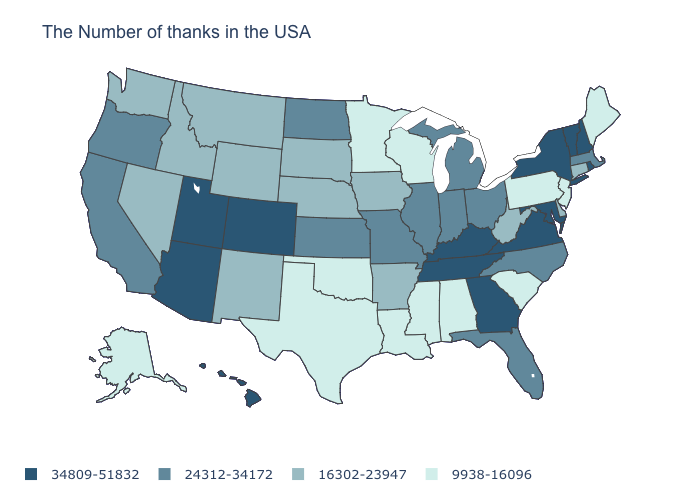Does Montana have the highest value in the West?
Keep it brief. No. Is the legend a continuous bar?
Keep it brief. No. What is the lowest value in states that border South Dakota?
Write a very short answer. 9938-16096. Is the legend a continuous bar?
Be succinct. No. Name the states that have a value in the range 16302-23947?
Write a very short answer. Connecticut, Delaware, West Virginia, Arkansas, Iowa, Nebraska, South Dakota, Wyoming, New Mexico, Montana, Idaho, Nevada, Washington. Among the states that border South Carolina , which have the lowest value?
Keep it brief. North Carolina. Name the states that have a value in the range 16302-23947?
Keep it brief. Connecticut, Delaware, West Virginia, Arkansas, Iowa, Nebraska, South Dakota, Wyoming, New Mexico, Montana, Idaho, Nevada, Washington. What is the value of Ohio?
Short answer required. 24312-34172. Does the map have missing data?
Keep it brief. No. Does Delaware have a lower value than Georgia?
Give a very brief answer. Yes. Name the states that have a value in the range 9938-16096?
Short answer required. Maine, New Jersey, Pennsylvania, South Carolina, Alabama, Wisconsin, Mississippi, Louisiana, Minnesota, Oklahoma, Texas, Alaska. Name the states that have a value in the range 24312-34172?
Short answer required. Massachusetts, North Carolina, Ohio, Florida, Michigan, Indiana, Illinois, Missouri, Kansas, North Dakota, California, Oregon. Name the states that have a value in the range 24312-34172?
Concise answer only. Massachusetts, North Carolina, Ohio, Florida, Michigan, Indiana, Illinois, Missouri, Kansas, North Dakota, California, Oregon. Does Oklahoma have the highest value in the South?
Short answer required. No. Name the states that have a value in the range 16302-23947?
Short answer required. Connecticut, Delaware, West Virginia, Arkansas, Iowa, Nebraska, South Dakota, Wyoming, New Mexico, Montana, Idaho, Nevada, Washington. 